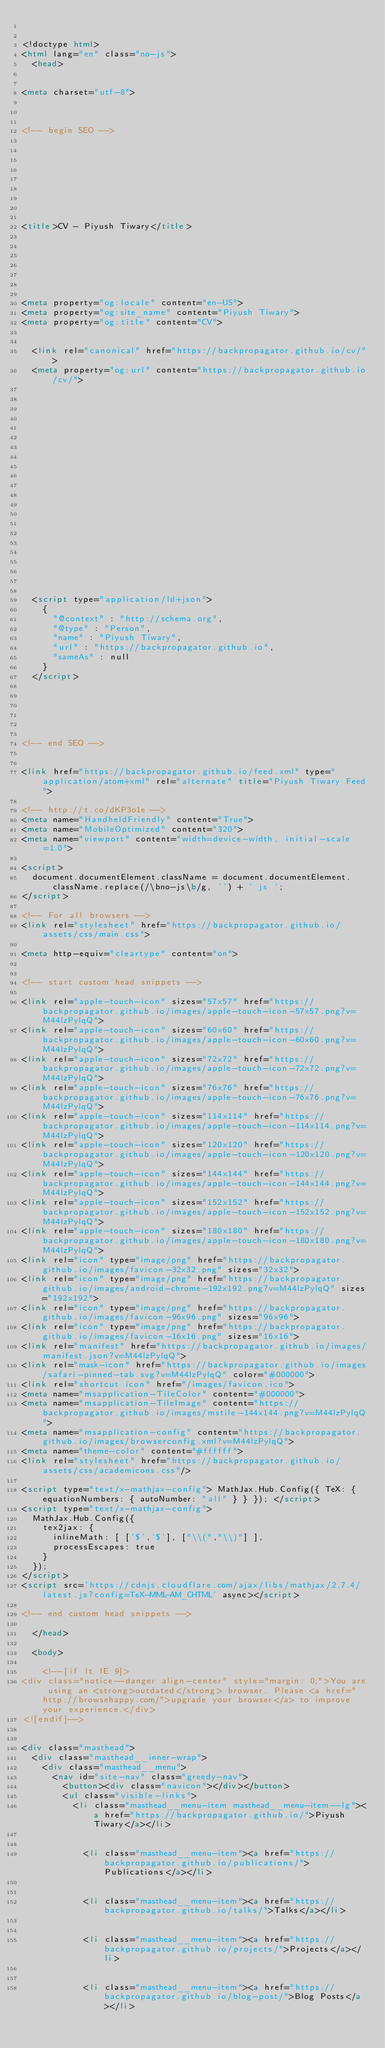Convert code to text. <code><loc_0><loc_0><loc_500><loc_500><_HTML_>

<!doctype html>
<html lang="en" class="no-js">
  <head>
    

<meta charset="utf-8">



<!-- begin SEO -->









<title>CV - Piyush Tiwary</title>







<meta property="og:locale" content="en-US">
<meta property="og:site_name" content="Piyush Tiwary">
<meta property="og:title" content="CV">


  <link rel="canonical" href="https://backpropagator.github.io/cv/">
  <meta property="og:url" content="https://backpropagator.github.io/cv/">







  

  












  <script type="application/ld+json">
    {
      "@context" : "http://schema.org",
      "@type" : "Person",
      "name" : "Piyush Tiwary",
      "url" : "https://backpropagator.github.io",
      "sameAs" : null
    }
  </script>






<!-- end SEO -->


<link href="https://backpropagator.github.io/feed.xml" type="application/atom+xml" rel="alternate" title="Piyush Tiwary Feed">

<!-- http://t.co/dKP3o1e -->
<meta name="HandheldFriendly" content="True">
<meta name="MobileOptimized" content="320">
<meta name="viewport" content="width=device-width, initial-scale=1.0">

<script>
  document.documentElement.className = document.documentElement.className.replace(/\bno-js\b/g, '') + ' js ';
</script>

<!-- For all browsers -->
<link rel="stylesheet" href="https://backpropagator.github.io/assets/css/main.css">

<meta http-equiv="cleartype" content="on">
    

<!-- start custom head snippets -->

<link rel="apple-touch-icon" sizes="57x57" href="https://backpropagator.github.io/images/apple-touch-icon-57x57.png?v=M44lzPylqQ">
<link rel="apple-touch-icon" sizes="60x60" href="https://backpropagator.github.io/images/apple-touch-icon-60x60.png?v=M44lzPylqQ">
<link rel="apple-touch-icon" sizes="72x72" href="https://backpropagator.github.io/images/apple-touch-icon-72x72.png?v=M44lzPylqQ">
<link rel="apple-touch-icon" sizes="76x76" href="https://backpropagator.github.io/images/apple-touch-icon-76x76.png?v=M44lzPylqQ">
<link rel="apple-touch-icon" sizes="114x114" href="https://backpropagator.github.io/images/apple-touch-icon-114x114.png?v=M44lzPylqQ">
<link rel="apple-touch-icon" sizes="120x120" href="https://backpropagator.github.io/images/apple-touch-icon-120x120.png?v=M44lzPylqQ">
<link rel="apple-touch-icon" sizes="144x144" href="https://backpropagator.github.io/images/apple-touch-icon-144x144.png?v=M44lzPylqQ">
<link rel="apple-touch-icon" sizes="152x152" href="https://backpropagator.github.io/images/apple-touch-icon-152x152.png?v=M44lzPylqQ">
<link rel="apple-touch-icon" sizes="180x180" href="https://backpropagator.github.io/images/apple-touch-icon-180x180.png?v=M44lzPylqQ">
<link rel="icon" type="image/png" href="https://backpropagator.github.io/images/favicon-32x32.png" sizes="32x32">
<link rel="icon" type="image/png" href="https://backpropagator.github.io/images/android-chrome-192x192.png?v=M44lzPylqQ" sizes="192x192">
<link rel="icon" type="image/png" href="https://backpropagator.github.io/images/favicon-96x96.png" sizes="96x96">
<link rel="icon" type="image/png" href="https://backpropagator.github.io/images/favicon-16x16.png" sizes="16x16">
<link rel="manifest" href="https://backpropagator.github.io/images/manifest.json?v=M44lzPylqQ">
<link rel="mask-icon" href="https://backpropagator.github.io/images/safari-pinned-tab.svg?v=M44lzPylqQ" color="#000000">
<link rel="shortcut icon" href="/images/favicon.ico">
<meta name="msapplication-TileColor" content="#000000">
<meta name="msapplication-TileImage" content="https://backpropagator.github.io/images/mstile-144x144.png?v=M44lzPylqQ">
<meta name="msapplication-config" content="https://backpropagator.github.io/images/browserconfig.xml?v=M44lzPylqQ">
<meta name="theme-color" content="#ffffff">
<link rel="stylesheet" href="https://backpropagator.github.io/assets/css/academicons.css"/>

<script type="text/x-mathjax-config"> MathJax.Hub.Config({ TeX: { equationNumbers: { autoNumber: "all" } } }); </script>
<script type="text/x-mathjax-config">
  MathJax.Hub.Config({
    tex2jax: {
      inlineMath: [ ['$','$'], ["\\(","\\)"] ],
      processEscapes: true
    }
  });
</script>
<script src='https://cdnjs.cloudflare.com/ajax/libs/mathjax/2.7.4/latest.js?config=TeX-MML-AM_CHTML' async></script>

<!-- end custom head snippets -->

  </head>

  <body>

    <!--[if lt IE 9]>
<div class="notice--danger align-center" style="margin: 0;">You are using an <strong>outdated</strong> browser. Please <a href="http://browsehappy.com/">upgrade your browser</a> to improve your experience.</div>
<![endif]-->
    

<div class="masthead">
  <div class="masthead__inner-wrap">
    <div class="masthead__menu">
      <nav id="site-nav" class="greedy-nav">
        <button><div class="navicon"></div></button>
        <ul class="visible-links">
          <li class="masthead__menu-item masthead__menu-item--lg"><a href="https://backpropagator.github.io/">Piyush Tiwary</a></li>
          
            
            <li class="masthead__menu-item"><a href="https://backpropagator.github.io/publications/">Publications</a></li>
          
            
            <li class="masthead__menu-item"><a href="https://backpropagator.github.io/talks/">Talks</a></li>
          
            
            <li class="masthead__menu-item"><a href="https://backpropagator.github.io/projects/">Projects</a></li>
          
            
            <li class="masthead__menu-item"><a href="https://backpropagator.github.io/blog-post/">Blog Posts</a></li>
          
            </code> 